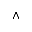<formula> <loc_0><loc_0><loc_500><loc_500>\land</formula> 